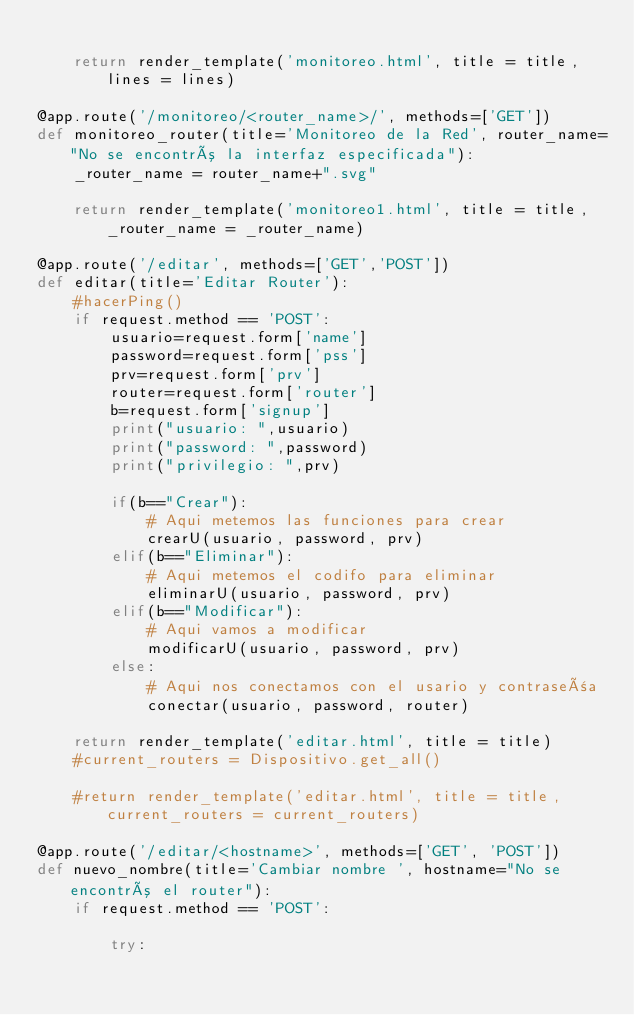<code> <loc_0><loc_0><loc_500><loc_500><_Python_>
	return render_template('monitoreo.html', title = title, lines = lines)

@app.route('/monitoreo/<router_name>/', methods=['GET'])
def monitoreo_router(title='Monitoreo de la Red', router_name="No se encontró la interfaz especificada"):
	_router_name = router_name+".svg"

	return render_template('monitoreo1.html', title = title, _router_name = _router_name)

@app.route('/editar', methods=['GET','POST'])
def editar(title='Editar Router'):
	#hacerPing()
	if request.method == 'POST':
		usuario=request.form['name']
		password=request.form['pss']
		prv=request.form['prv']
		router=request.form['router']
		b=request.form['signup']
		print("usuario: ",usuario)
		print("password: ",password)
		print("privilegio: ",prv)

		if(b=="Crear"):
			# Aqui metemos las funciones para crear
			crearU(usuario, password, prv)
		elif(b=="Eliminar"):
			# Aqui metemos el codifo para eliminar
			eliminarU(usuario, password, prv)
		elif(b=="Modificar"):
			# Aqui vamos a modificar
			modificarU(usuario, password, prv)
		else:
			# Aqui nos conectamos con el usario y contraseña
			conectar(usuario, password, router)

	return render_template('editar.html', title = title)
	#current_routers = Dispositivo.get_all()

	#return render_template('editar.html', title = title, current_routers = current_routers)

@app.route('/editar/<hostname>', methods=['GET', 'POST'])
def nuevo_nombre(title='Cambiar nombre ', hostname="No se encontró el router"):
	if request.method == 'POST':

		try:	</code> 